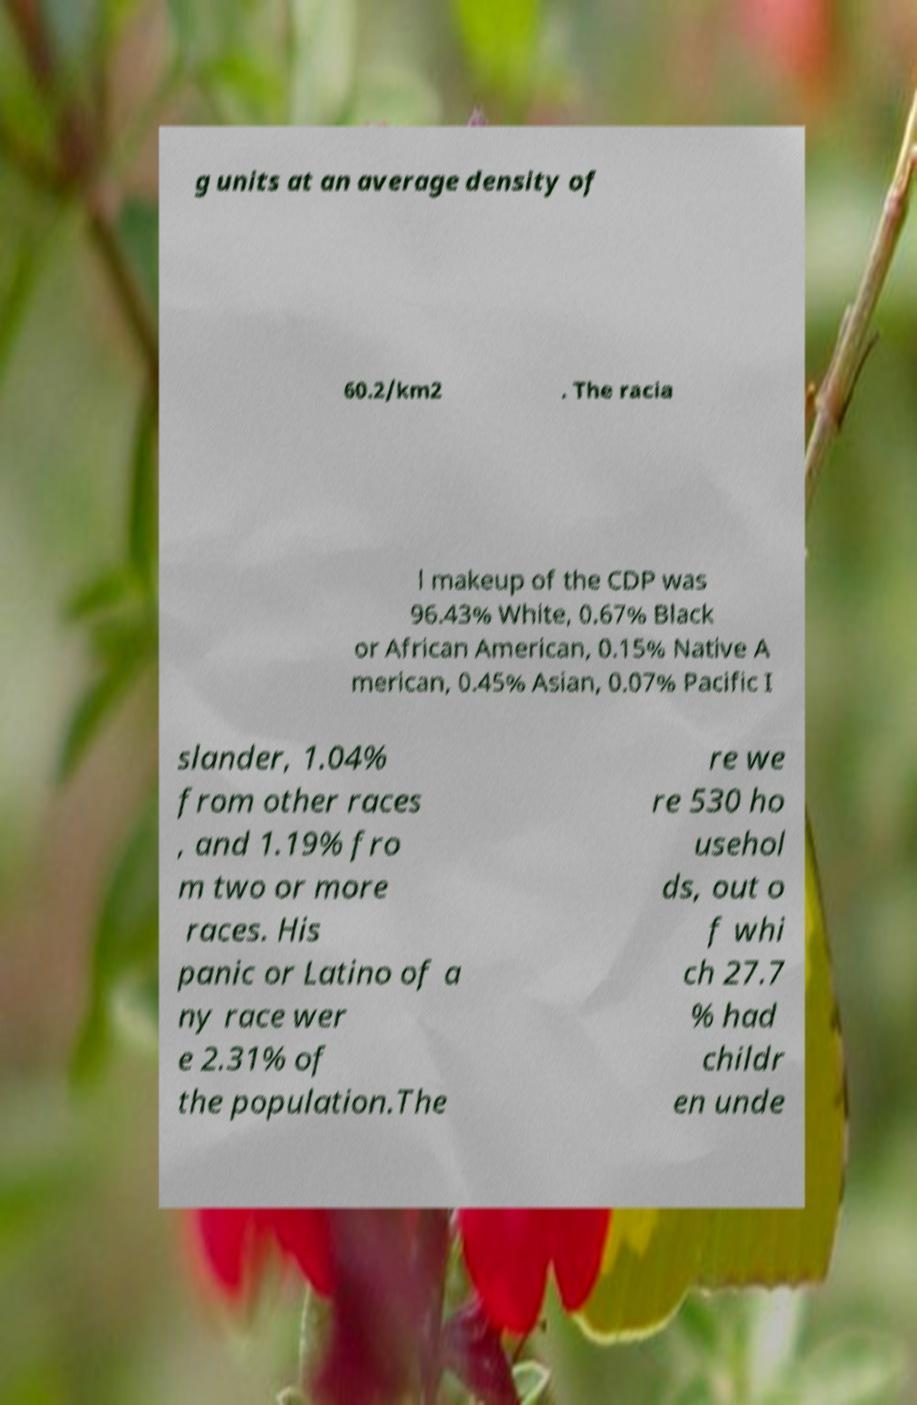What messages or text are displayed in this image? I need them in a readable, typed format. g units at an average density of 60.2/km2 . The racia l makeup of the CDP was 96.43% White, 0.67% Black or African American, 0.15% Native A merican, 0.45% Asian, 0.07% Pacific I slander, 1.04% from other races , and 1.19% fro m two or more races. His panic or Latino of a ny race wer e 2.31% of the population.The re we re 530 ho usehol ds, out o f whi ch 27.7 % had childr en unde 